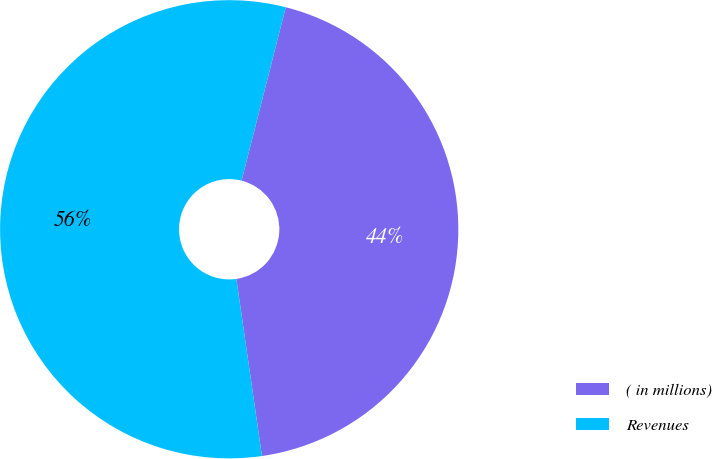Convert chart to OTSL. <chart><loc_0><loc_0><loc_500><loc_500><pie_chart><fcel>( in millions)<fcel>Revenues<nl><fcel>43.75%<fcel>56.25%<nl></chart> 